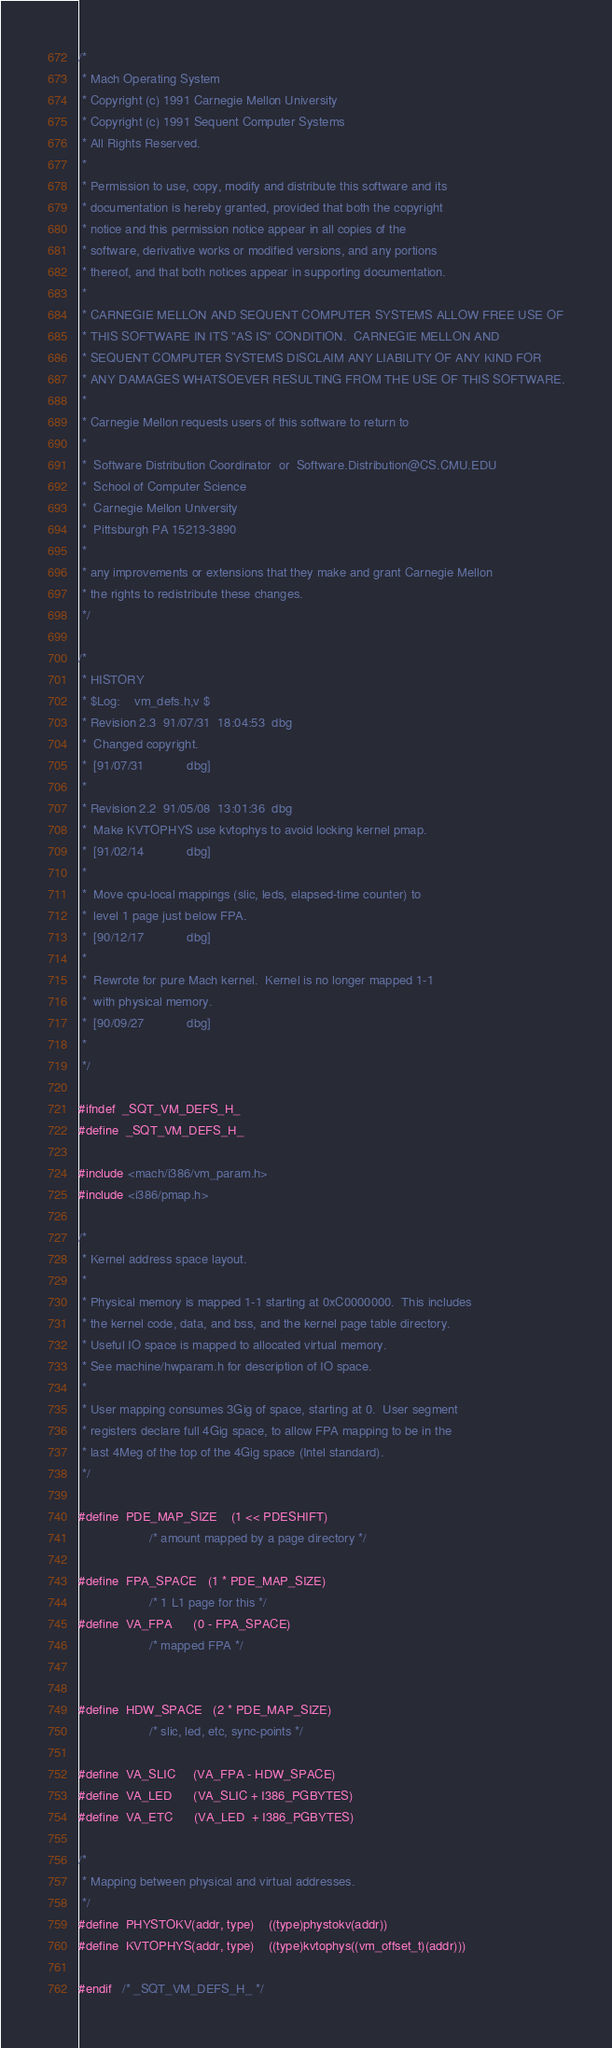Convert code to text. <code><loc_0><loc_0><loc_500><loc_500><_C_>/* 
 * Mach Operating System
 * Copyright (c) 1991 Carnegie Mellon University
 * Copyright (c) 1991 Sequent Computer Systems
 * All Rights Reserved.
 * 
 * Permission to use, copy, modify and distribute this software and its
 * documentation is hereby granted, provided that both the copyright
 * notice and this permission notice appear in all copies of the
 * software, derivative works or modified versions, and any portions
 * thereof, and that both notices appear in supporting documentation.
 * 
 * CARNEGIE MELLON AND SEQUENT COMPUTER SYSTEMS ALLOW FREE USE OF
 * THIS SOFTWARE IN ITS "AS IS" CONDITION.  CARNEGIE MELLON AND
 * SEQUENT COMPUTER SYSTEMS DISCLAIM ANY LIABILITY OF ANY KIND FOR
 * ANY DAMAGES WHATSOEVER RESULTING FROM THE USE OF THIS SOFTWARE.
 * 
 * Carnegie Mellon requests users of this software to return to
 * 
 *  Software Distribution Coordinator  or  Software.Distribution@CS.CMU.EDU
 *  School of Computer Science
 *  Carnegie Mellon University
 *  Pittsburgh PA 15213-3890
 * 
 * any improvements or extensions that they make and grant Carnegie Mellon 
 * the rights to redistribute these changes.
 */

/*
 * HISTORY
 * $Log:	vm_defs.h,v $
 * Revision 2.3  91/07/31  18:04:53  dbg
 * 	Changed copyright.
 * 	[91/07/31            dbg]
 * 
 * Revision 2.2  91/05/08  13:01:36  dbg
 * 	Make KVTOPHYS use kvtophys to avoid locking kernel pmap.
 * 	[91/02/14            dbg]
 * 
 * 	Move cpu-local mappings (slic, leds, elapsed-time counter) to
 * 	level 1 page just below FPA.
 * 	[90/12/17            dbg]
 * 
 * 	Rewrote for pure Mach kernel.  Kernel is no longer mapped 1-1
 * 	with physical memory.
 * 	[90/09/27            dbg]
 * 
 */

#ifndef	_SQT_VM_DEFS_H_
#define	_SQT_VM_DEFS_H_

#include <mach/i386/vm_param.h>
#include <i386/pmap.h>

/*
 * Kernel address space layout.
 *
 * Physical memory is mapped 1-1 starting at 0xC0000000.  This includes
 * the kernel code, data, and bss, and the kernel page table directory.
 * Useful IO space is mapped to allocated virtual memory.
 * See machine/hwparam.h for description of IO space.
 *
 * User mapping consumes 3Gig of space, starting at 0.  User segment
 * registers declare full 4Gig space, to allow FPA mapping to be in the
 * last 4Meg of the top of the 4Gig space (Intel standard).
 */

#define	PDE_MAP_SIZE	(1 << PDESHIFT)
					/* amount mapped by a page directory */

#define	FPA_SPACE	(1 * PDE_MAP_SIZE)
					/* 1 L1 page for this */
#define	VA_FPA		(0 - FPA_SPACE)
					/* mapped FPA */


#define	HDW_SPACE	(2 * PDE_MAP_SIZE)
					/* slic, led, etc, sync-points */

#define	VA_SLIC		(VA_FPA - HDW_SPACE)
#define	VA_LED		(VA_SLIC + I386_PGBYTES)
#define	VA_ETC		(VA_LED  + I386_PGBYTES)

/*
 * Mapping between physical and virtual addresses.
 */
#define	PHYSTOKV(addr, type)	((type)phystokv(addr))
#define	KVTOPHYS(addr, type)	((type)kvtophys((vm_offset_t)(addr)))

#endif	/* _SQT_VM_DEFS_H_ */
</code> 